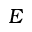Convert formula to latex. <formula><loc_0><loc_0><loc_500><loc_500>E</formula> 